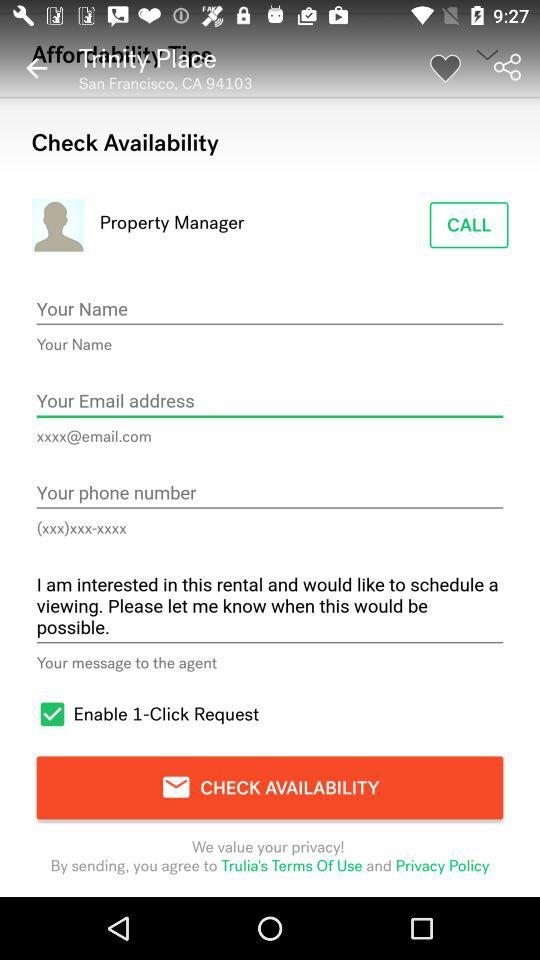What is the location? The location is San Francisco, CA 94103. 